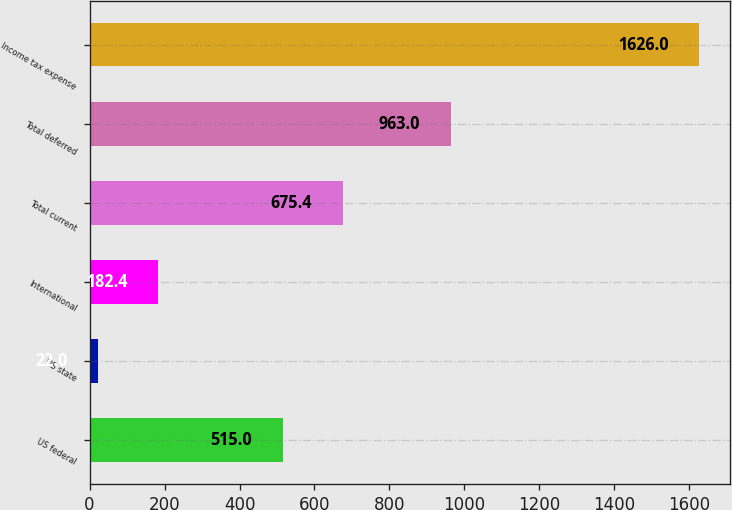Convert chart. <chart><loc_0><loc_0><loc_500><loc_500><bar_chart><fcel>US federal<fcel>US state<fcel>International<fcel>Total current<fcel>Total deferred<fcel>Income tax expense<nl><fcel>515<fcel>22<fcel>182.4<fcel>675.4<fcel>963<fcel>1626<nl></chart> 